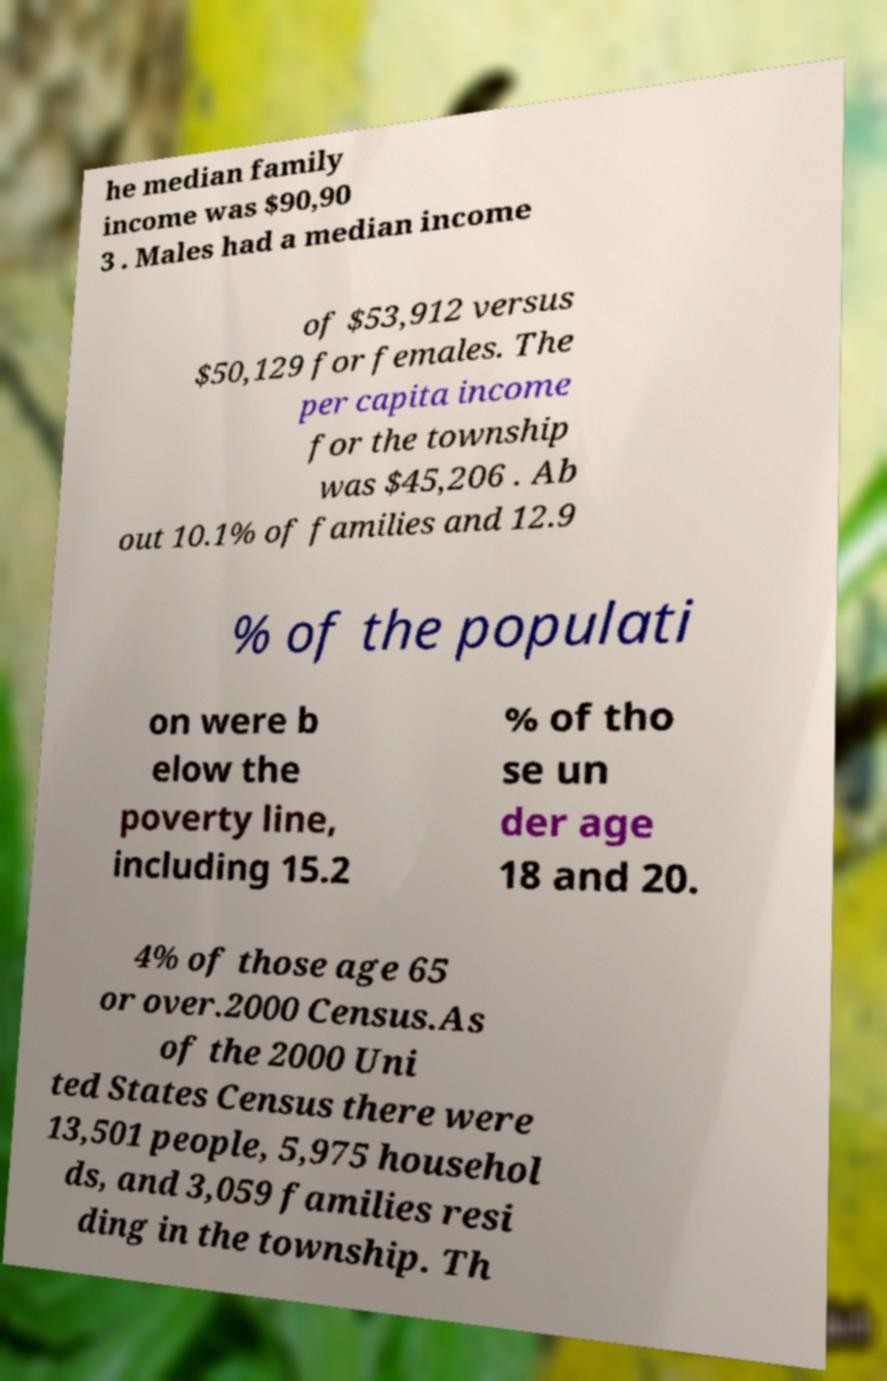What messages or text are displayed in this image? I need them in a readable, typed format. he median family income was $90,90 3 . Males had a median income of $53,912 versus $50,129 for females. The per capita income for the township was $45,206 . Ab out 10.1% of families and 12.9 % of the populati on were b elow the poverty line, including 15.2 % of tho se un der age 18 and 20. 4% of those age 65 or over.2000 Census.As of the 2000 Uni ted States Census there were 13,501 people, 5,975 househol ds, and 3,059 families resi ding in the township. Th 